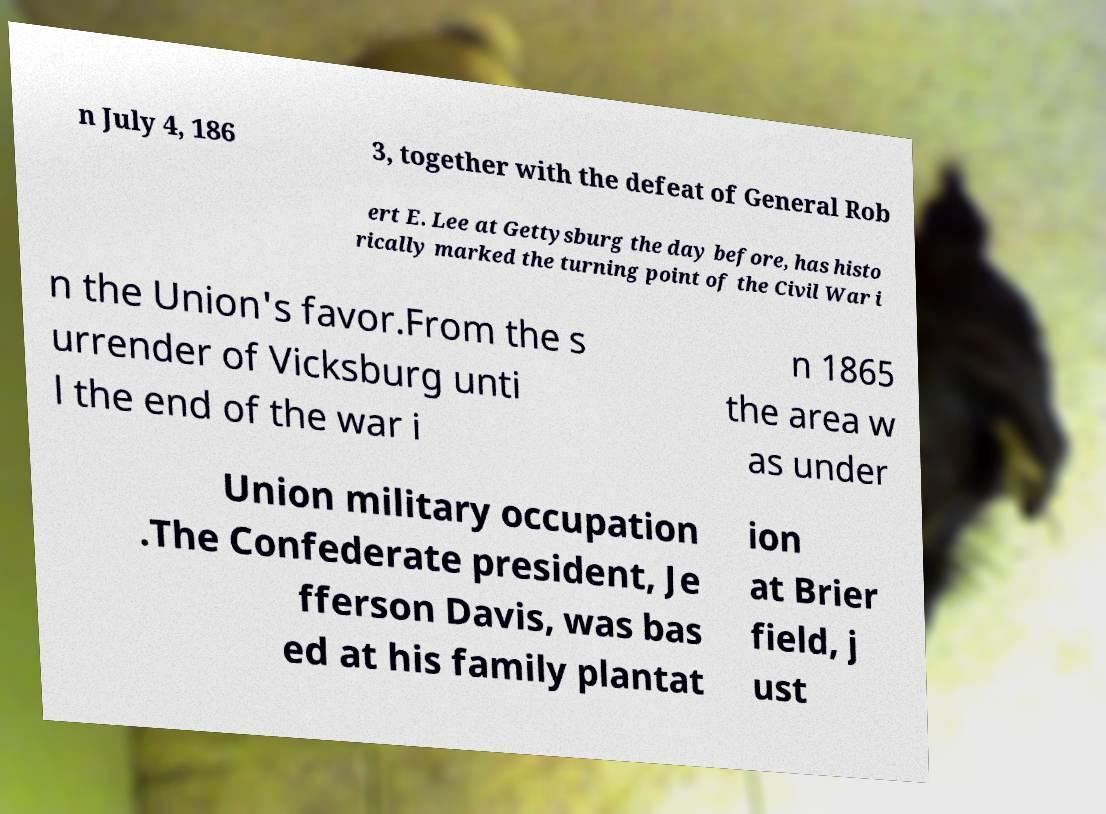Could you extract and type out the text from this image? n July 4, 186 3, together with the defeat of General Rob ert E. Lee at Gettysburg the day before, has histo rically marked the turning point of the Civil War i n the Union's favor.From the s urrender of Vicksburg unti l the end of the war i n 1865 the area w as under Union military occupation .The Confederate president, Je fferson Davis, was bas ed at his family plantat ion at Brier field, j ust 